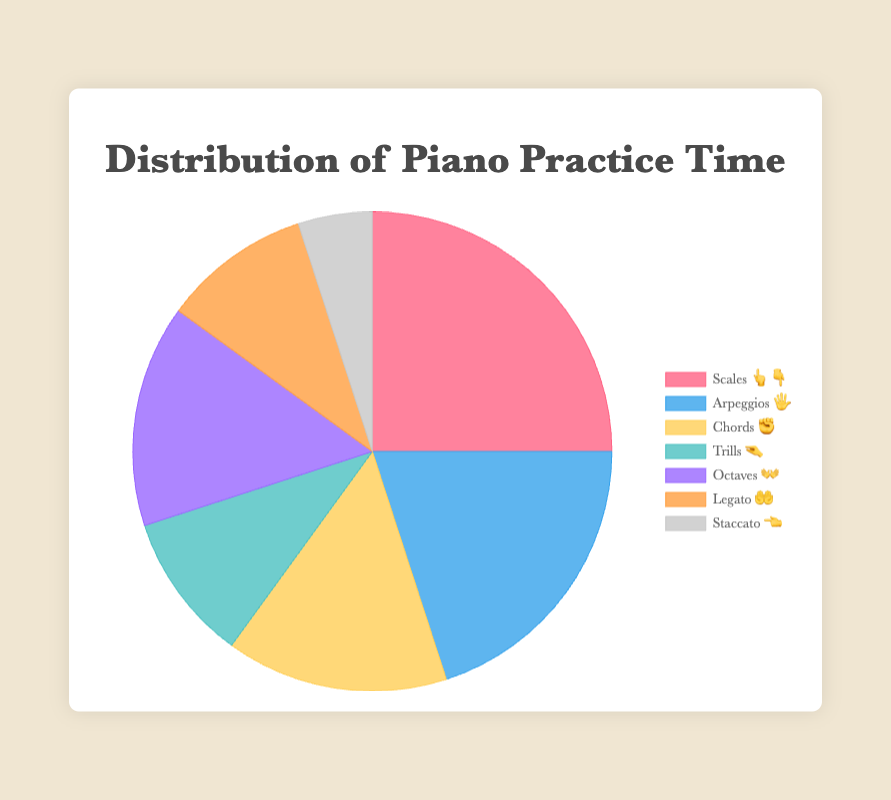What's the title of the chart? The title is displayed at the top of the chart.
Answer: Distribution of Piano Practice Time Which piano technique has the highest practice time? By looking at the sections of the pie chart, the largest section represents the technique with the highest practice time.
Answer: Scales 👆👇 What is the practice time for the technique represented by the emoji "✊"? Locate the emoji representing "✊" in the legend, and find the corresponding pie section to see the practice time.
Answer: 15 What is the combined practice time for Trills 🤏 and Legato 🤲? Find the practice times for both Trills (10) and Legato (10) from the chart, then add them together.
Answer: 20 Which technique has more practice time: Chords ✊ or Octaves 👐? Compare the sizes of the pie chart sections and the practice times in the legend for Chords (15) and Octaves (15).
Answer: Equal How much more practice time does Scales 👆👇 have compared to Staccato 👈? Subtract the practice time of Staccato (5) from the practice time of Scales (25).
Answer: 20 What percentage of total practice time is dedicated to Arpeggios 🖐️? Since the chart sections are labeled with percentages, locate Arpeggios and note its percentage.
Answer: 20% Which two techniques both have 10% of the practice time? Locate the sections with 10% in the pie chart or legend.
Answer: Trills 🤏 and Legato 🤲 What is the sum of practice times for all techniques? Add the practice times for all techniques: 25 + 20 + 15 + 10 + 15 + 10 + 5.
Answer: 100 If the total practice time is 100 minutes, how many minutes does each percent represent? Since 100 minutes total is 100%, 1 minute represents 1%.
Answer: 1 